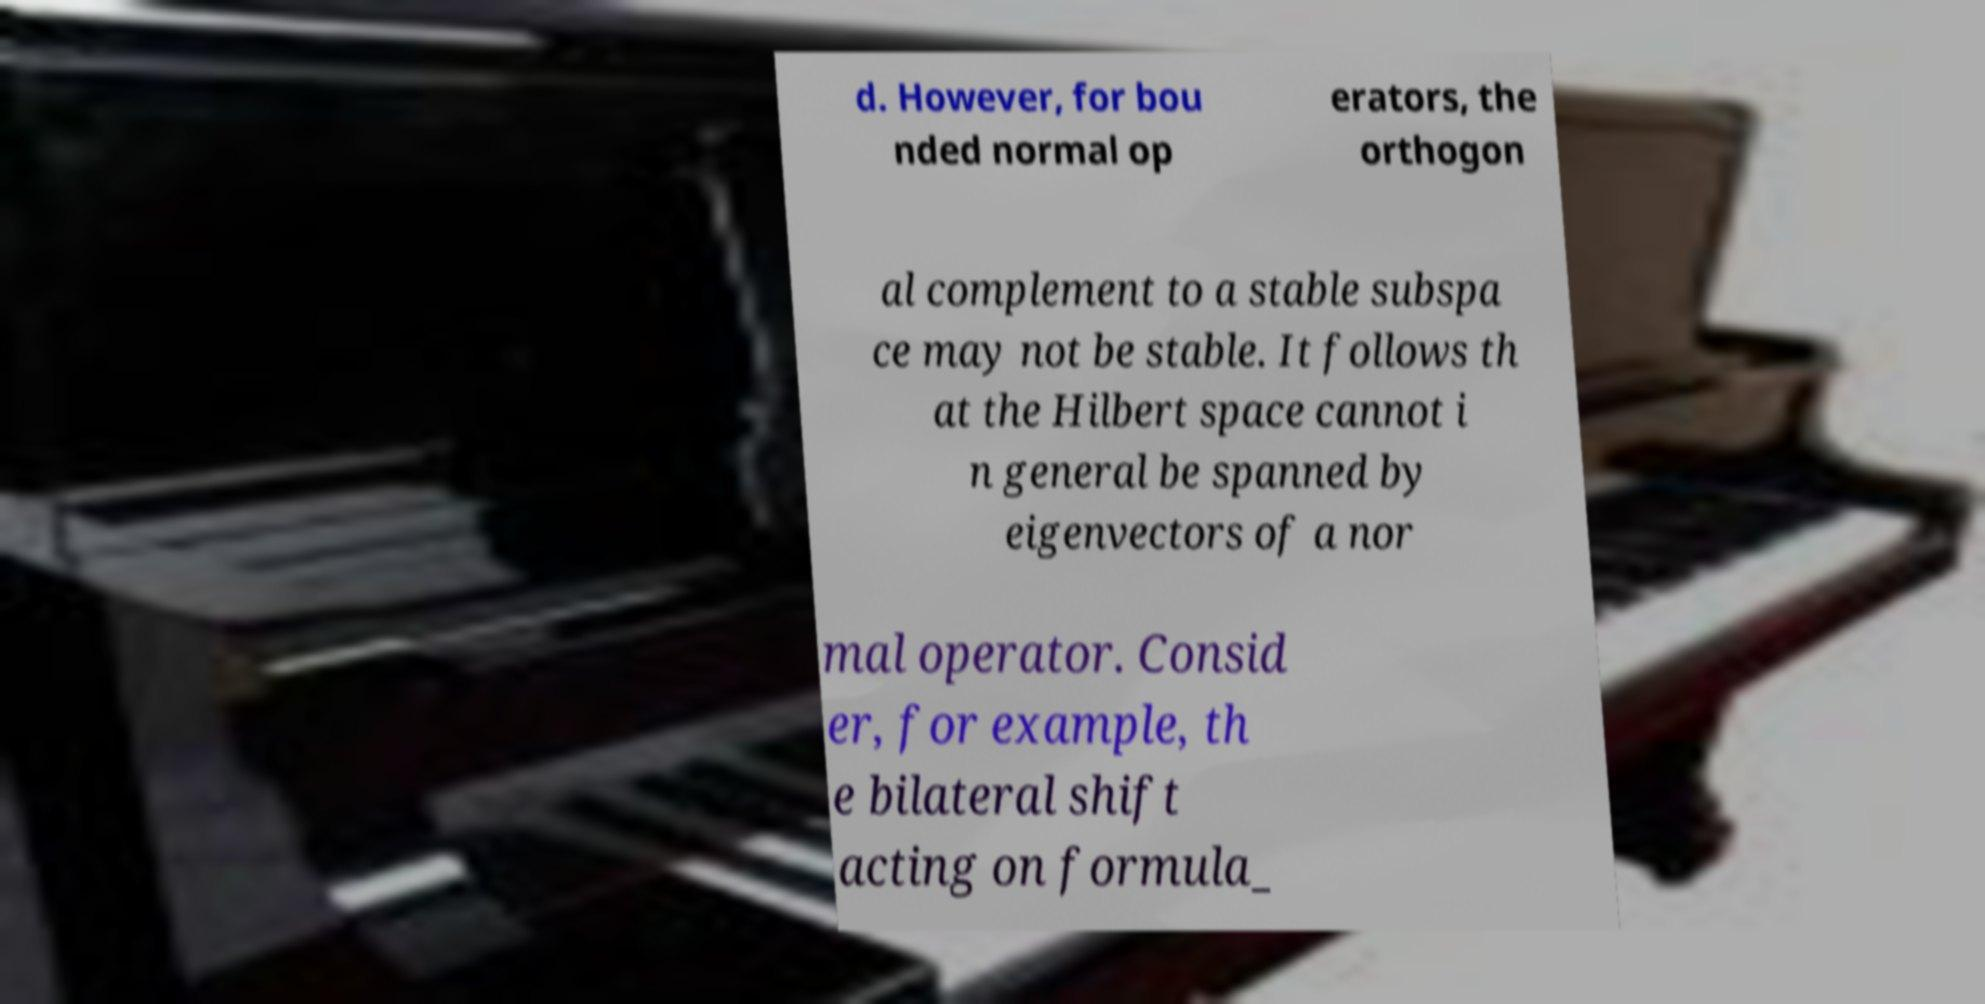Can you accurately transcribe the text from the provided image for me? d. However, for bou nded normal op erators, the orthogon al complement to a stable subspa ce may not be stable. It follows th at the Hilbert space cannot i n general be spanned by eigenvectors of a nor mal operator. Consid er, for example, th e bilateral shift acting on formula_ 